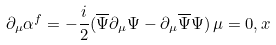<formula> <loc_0><loc_0><loc_500><loc_500>\partial _ { \mu } \alpha ^ { f } = - \frac { i } { 2 } ( \overline { \Psi } \partial _ { \mu } \Psi - \partial _ { \mu } \overline { \Psi } \Psi ) \, \mu = 0 , x</formula> 